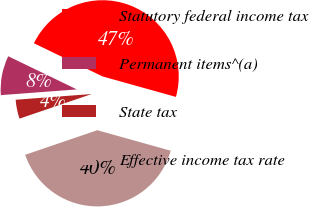Convert chart to OTSL. <chart><loc_0><loc_0><loc_500><loc_500><pie_chart><fcel>Statutory federal income tax<fcel>Permanent items^(a)<fcel>State tax<fcel>Effective income tax rate<nl><fcel>47.17%<fcel>8.36%<fcel>4.04%<fcel>40.43%<nl></chart> 